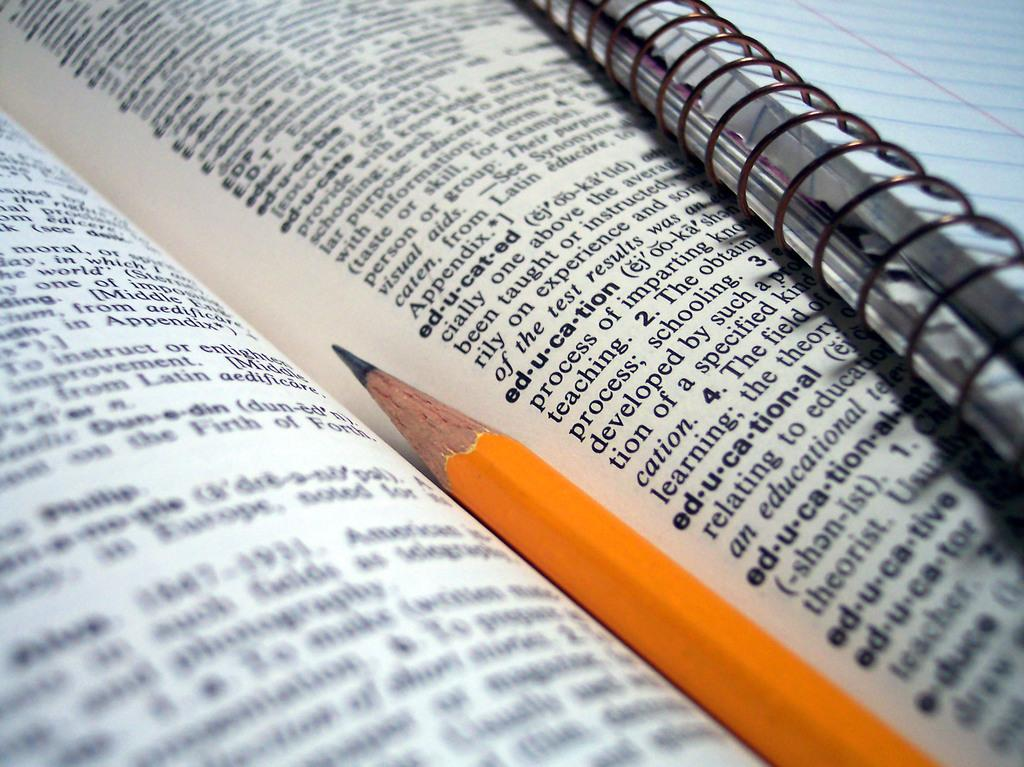Provide a one-sentence caption for the provided image. A dictionary opened to a page with e words and with a pencil between the pages. 